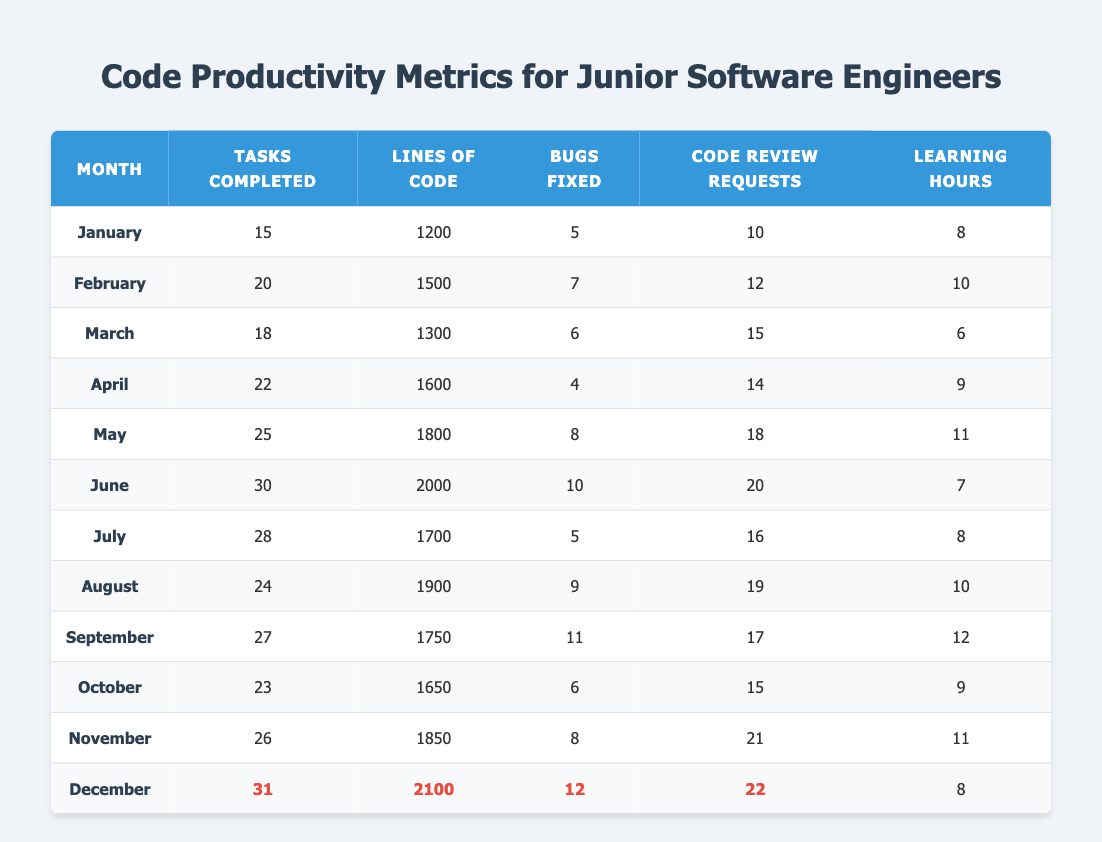What is the total number of tasks completed in June and July? The tasks completed in June are 30 and in July are 28. To find the total, we add these numbers together: 30 + 28 = 58.
Answer: 58 In which month did the highest number of lines of code get written? Looking at the "Lines of Code" column, December has the highest value of 2100 lines of code.
Answer: December What is the average number of learning hours across all months? To calculate the average, we sum the learning hours from each month: (8 + 10 + 6 + 9 + 11 + 7 + 8 + 10 + 12 + 9 + 11 + 8) =  117. There are 12 months, so the average is 117 / 12 = 9.75.
Answer: 9.75 Did more code review requests occur in November compared to January? In November, there were 21 code review requests, while in January there were 10. Since 21 is greater than 10, the statement is true.
Answer: Yes How many bugs were fixed in total from March to May? In March, 6 bugs were fixed, in April 4, and in May 8. We add these together: 6 + 4 + 8 = 18.
Answer: 18 Was the number of tasks completed in September greater than the number of bugs fixed in December? In September, 27 tasks were completed and in December 12 bugs were fixed. The comparison shows that 27 (tasks) is greater than 12 (bugs fixed), so the statement is true.
Answer: Yes What is the difference in tasks completed between the highest and lowest months? The highest number of tasks completed was in June with 30 tasks, and the lowest was in January with 15 tasks. The difference is 30 - 15 = 15.
Answer: 15 Which month had the least number of bugs fixed? The least number of bugs fixed was in April, where only 4 bugs were fixed according to the data.
Answer: April How many more code review requests were made in August than June? In August, 19 code review requests were made and in June, 20 were made. To find the difference: 19 - 20 = -1, which indicates that August had 1 less request than June.
Answer: 1 less 